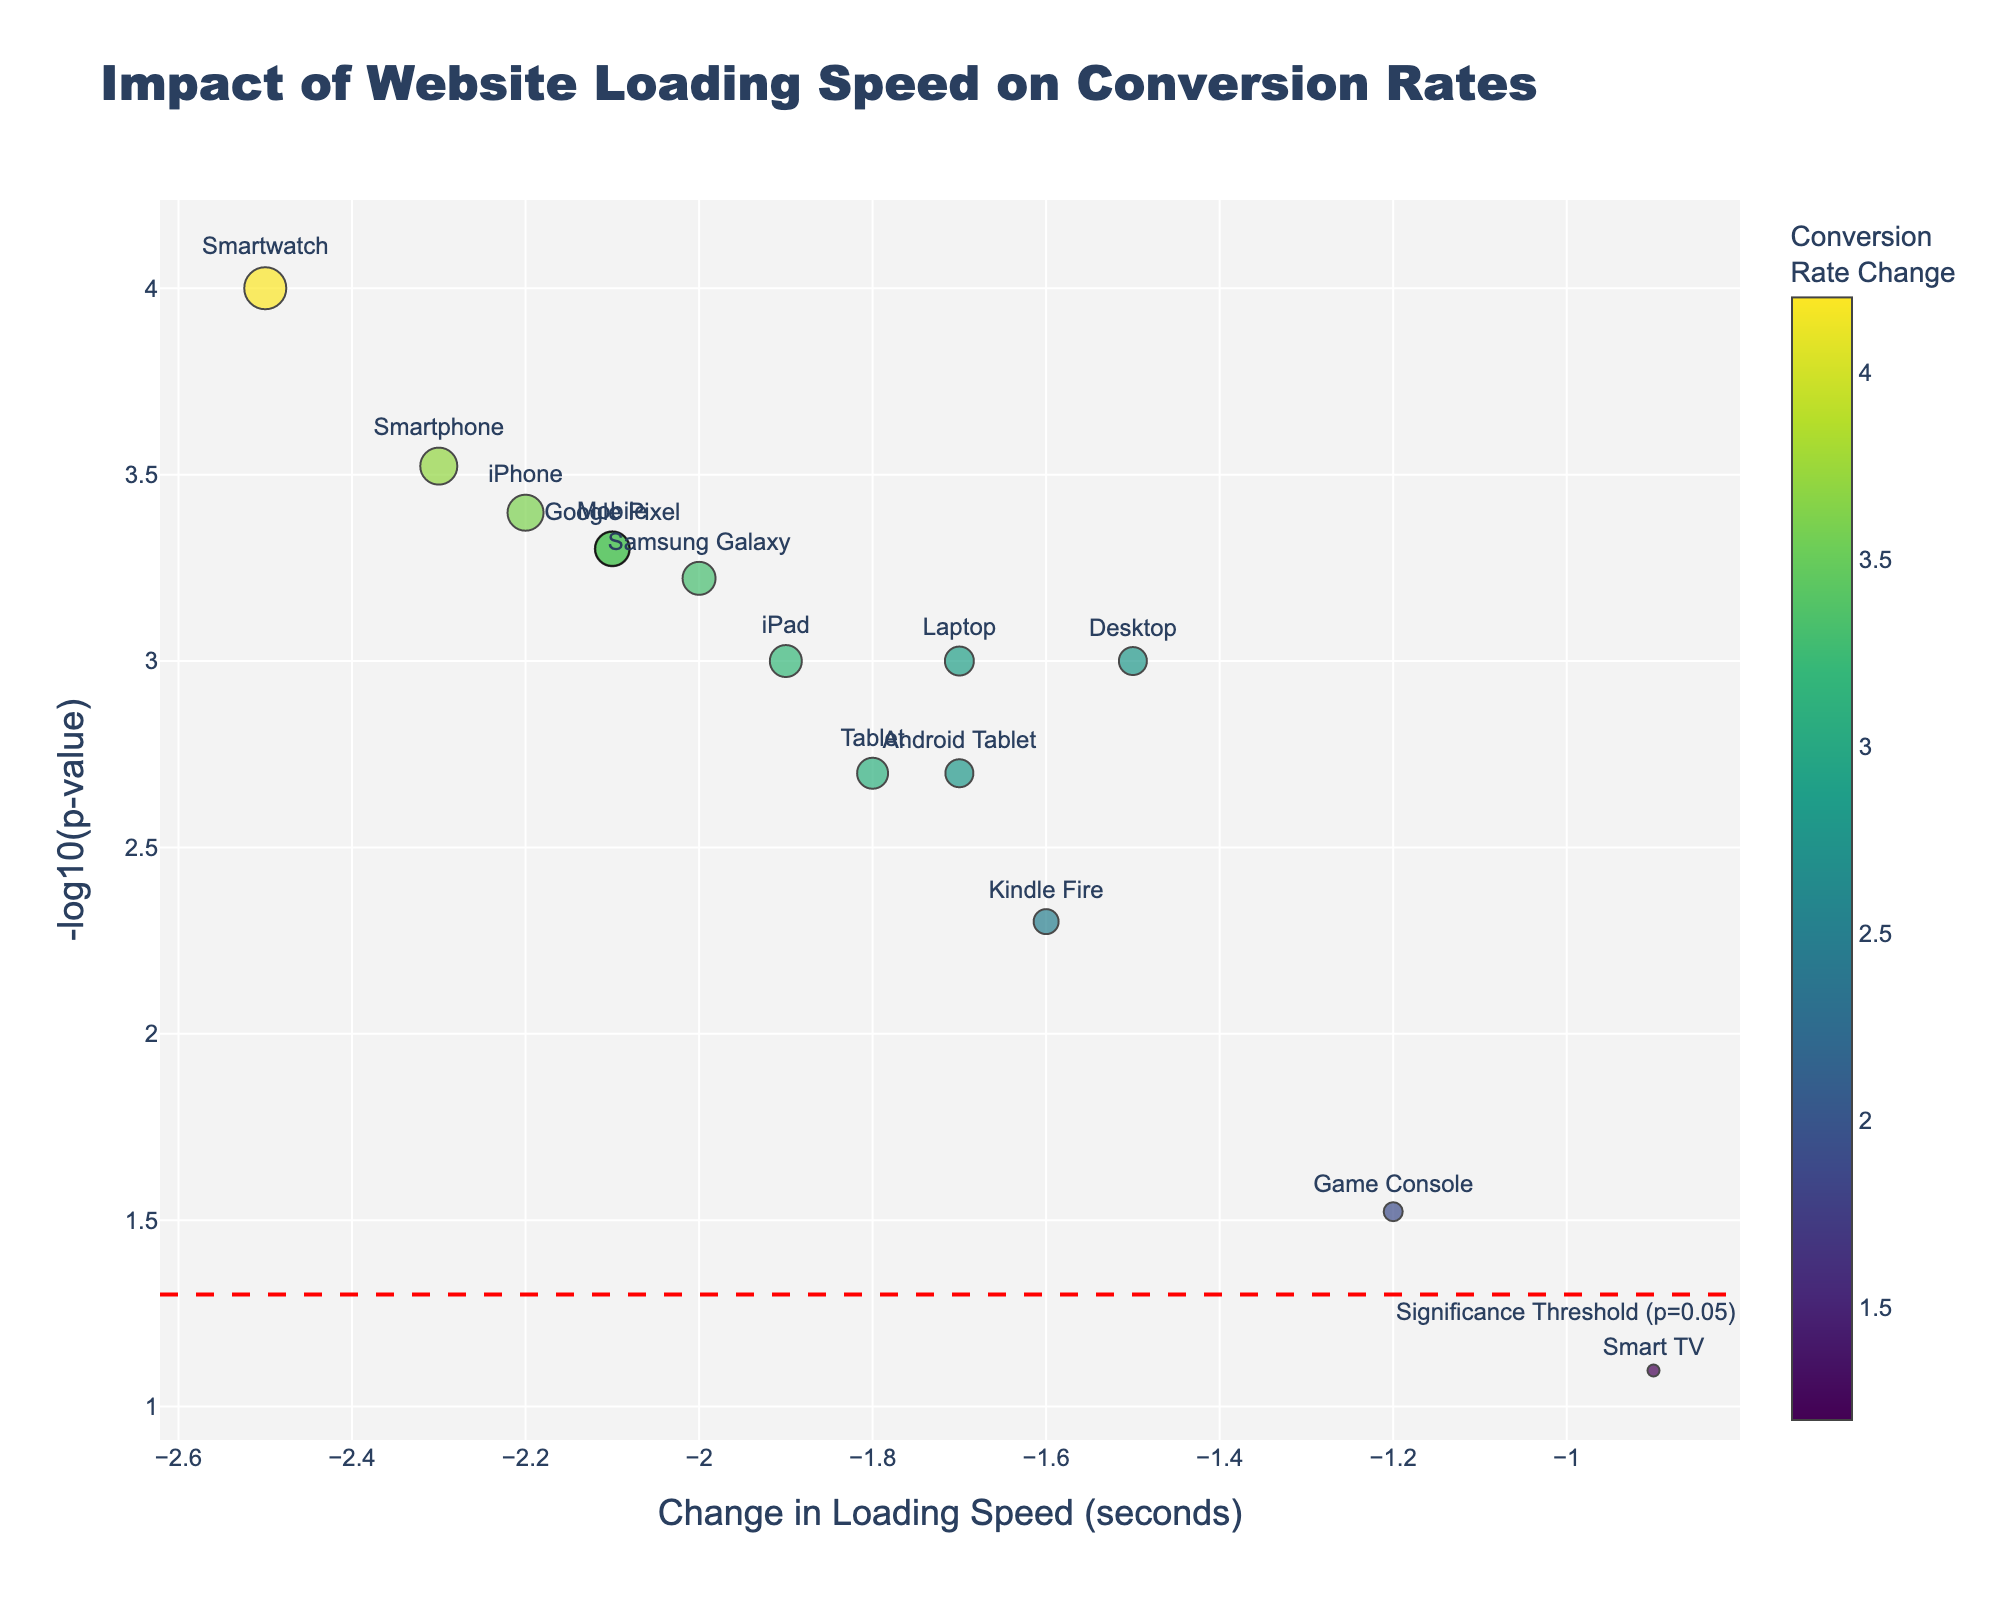How many device types are plotted in the figure? Count the number of unique device types listed, each represented by a data point.
Answer: 14 What does the y-axis represent? The y-axis represents the -log10(p-value), indicating statistical significance, where higher values are more significant.
Answer: -log10(p-value) Which device shows the highest conversion rate change? By observing the size and color of the markers, the device with the largest, most intensely colored marker denotes the highest conversion rate change. The Smartwatch shows the highest change.
Answer: Smartwatch What is the significance threshold line? There's a horizontal line on the plot annotated as "Significance Threshold (p=0.05)", which corresponds to a -log10(p-value) of approximately 1.30.
Answer: -log10(p-value) = 1.30 Which device has the lowest p-value, and what does this imply? The device with the highest -log10(p-value) has the lowest p-value, meaning it is statistically the most significant. The Smartwatch has the highest -log10(p-value).
Answer: Smartwatch How does the loading speed change for Desktop compare to Mobile? Compare the x-axis values for both devices. Desktop has a loading speed change of -1.5 seconds and Mobile -2.1 seconds.
Answer: Desktop: -1.5s, Mobile: -2.1s What is the conversion rate change for devices below the significance threshold? Devices below the threshold line are not considered statistically significant. The Smart TV, with a conversion rate change of 1.2%, is below this line.
Answer: 1.2% What does a marker's size represent in the plot? The marker size represents the conversion rate change percentage, with larger markers indicating higher conversion rate changes.
Answer: Conversion rate change Which device has a loading speed change of around -2.0 seconds and a p-value indicating high significance? Identify the device around -2.0 seconds on the x-axis and with a high -log10(p-value). The iPhone, with a -2.2 seconds change, is highly significant.
Answer: iPhone On average, how significant are the changes in conversion rates for devices other than Smartwatch? Calculate the average of -log10(p-value) values for all devices except Smartwatch, which has the maximum -log10(p-value). ((2.8 + 3.0 + 2.6 + 1.07 + 2.2 + 3.0 + 2.5 + 3.0 + 2.6 + 2.8 + 3.1 + 2.3) / 12) ≈ 2.7
Answer: ≈ 2.7 